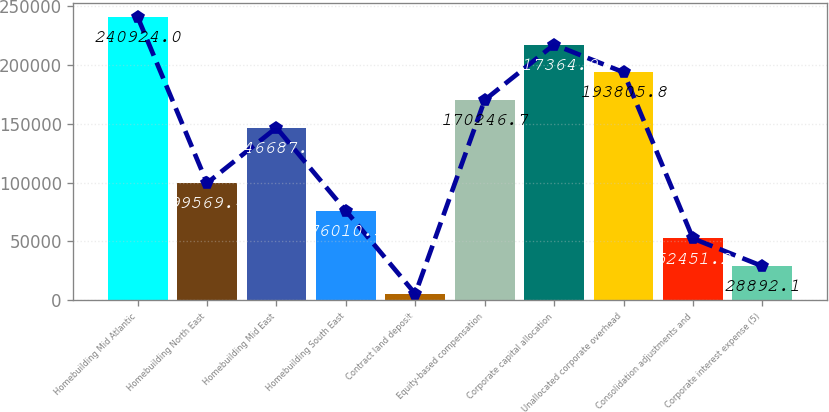Convert chart to OTSL. <chart><loc_0><loc_0><loc_500><loc_500><bar_chart><fcel>Homebuilding Mid Atlantic<fcel>Homebuilding North East<fcel>Homebuilding Mid East<fcel>Homebuilding South East<fcel>Contract land deposit<fcel>Equity-based compensation<fcel>Corporate capital allocation<fcel>Unallocated corporate overhead<fcel>Consolidation adjustments and<fcel>Corporate interest expense (5)<nl><fcel>240924<fcel>99569.4<fcel>146688<fcel>76010.3<fcel>5333<fcel>170247<fcel>217365<fcel>193806<fcel>52451.2<fcel>28892.1<nl></chart> 